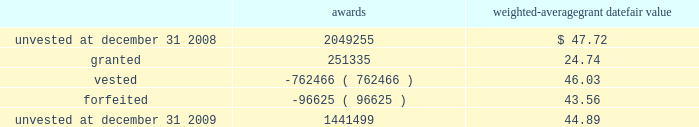Marathon oil corporation notes to consolidated financial statements restricted stock awards the following is a summary of restricted stock award activity .
Awards weighted-average grant date fair value .
The vesting date fair value of restricted stock awards which vested during 2009 , 2008 and 2007 was $ 24 million , $ 38 million and $ 29 million .
The weighted average grant date fair value of restricted stock awards was $ 44.89 , $ 47.72 , and $ 39.87 for awards unvested at december 31 , 2009 , 2008 and 2007 .
As of december 31 , 2009 , there was $ 43 million of unrecognized compensation cost related to restricted stock awards which is expected to be recognized over a weighted average period of 1.6 years .
Stock-based performance awards all stock-based performance awards have either vested or been forfeited .
The vesting date fair value of stock- based performance awards which vested during 2007 was $ 38 .
24 .
Stockholders 2019 equity in each year , 2009 and 2008 , we issued 2 million in common stock upon the redemption of the exchangeable shares described below in addition to treasury shares issued for employee stock-based awards .
The board of directors has authorized the repurchase of up to $ 5 billion of marathon common stock .
Purchases under the program may be in either open market transactions , including block purchases , or in privately negotiated transactions .
We will use cash on hand , cash generated from operations , proceeds from potential asset sales or cash from available borrowings to acquire shares .
This program may be changed based upon our financial condition or changes in market conditions and is subject to termination prior to completion .
The repurchase program does not include specific price targets or timetables .
As of december 31 , 2009 , we have acquired 66 million common shares at a cost of $ 2922 million under the program .
No shares have been acquired since august 2008 .
Securities exchangeable into marathon common stock 2013 as discussed in note 6 , we acquired all of the outstanding shares of western on october 18 , 2007 .
The western shareholders who were canadian residents received , at their election , cash , marathon common stock , securities exchangeable into marathon common stock ( the 201cexchangeable shares 201d ) or a combination thereof .
The western shareholders elected to receive 5 million exchangeable shares as part of the acquisition consideration .
The exchangeable shares are shares of an indirect canadian subsidiary of marathon and , at the acquisition date , were exchangeable on a one-for-one basis into marathon common stock .
Subsequent to the acquisition , the exchange ratio is adjusted to reflect cash dividends , if any , paid on marathon common stock and cash dividends , if any , paid on the exchangeable shares .
The exchange ratio at december 31 , 2009 , was 1.06109 common shares for each exchangeable share .
The exchangeable shares are exchangeable at the option of the holder at any time and are automatically redeemable on october 18 , 2011 .
Holders of exchangeable shares are entitled to instruct a trustee to vote ( or obtain a proxy from the trustee to vote directly ) on all matters submitted to the holders of marathon common stock .
The number of votes to which each holder is entitled is equal to the whole number of shares of marathon common stock into which such holder 2019s exchangeable shares would be exchangeable based on the exchange ratio in effect on the record date for the vote .
The voting right is attached to voting preferred shares of marathon that were issued to a trustee in an amount .
Based on the weighted average grant date fair value listed above , what was the value of unvested restricted stock awards at december 31 , 2009? 
Computations: (1441499 * 44.89)
Answer: 64708890.11. 